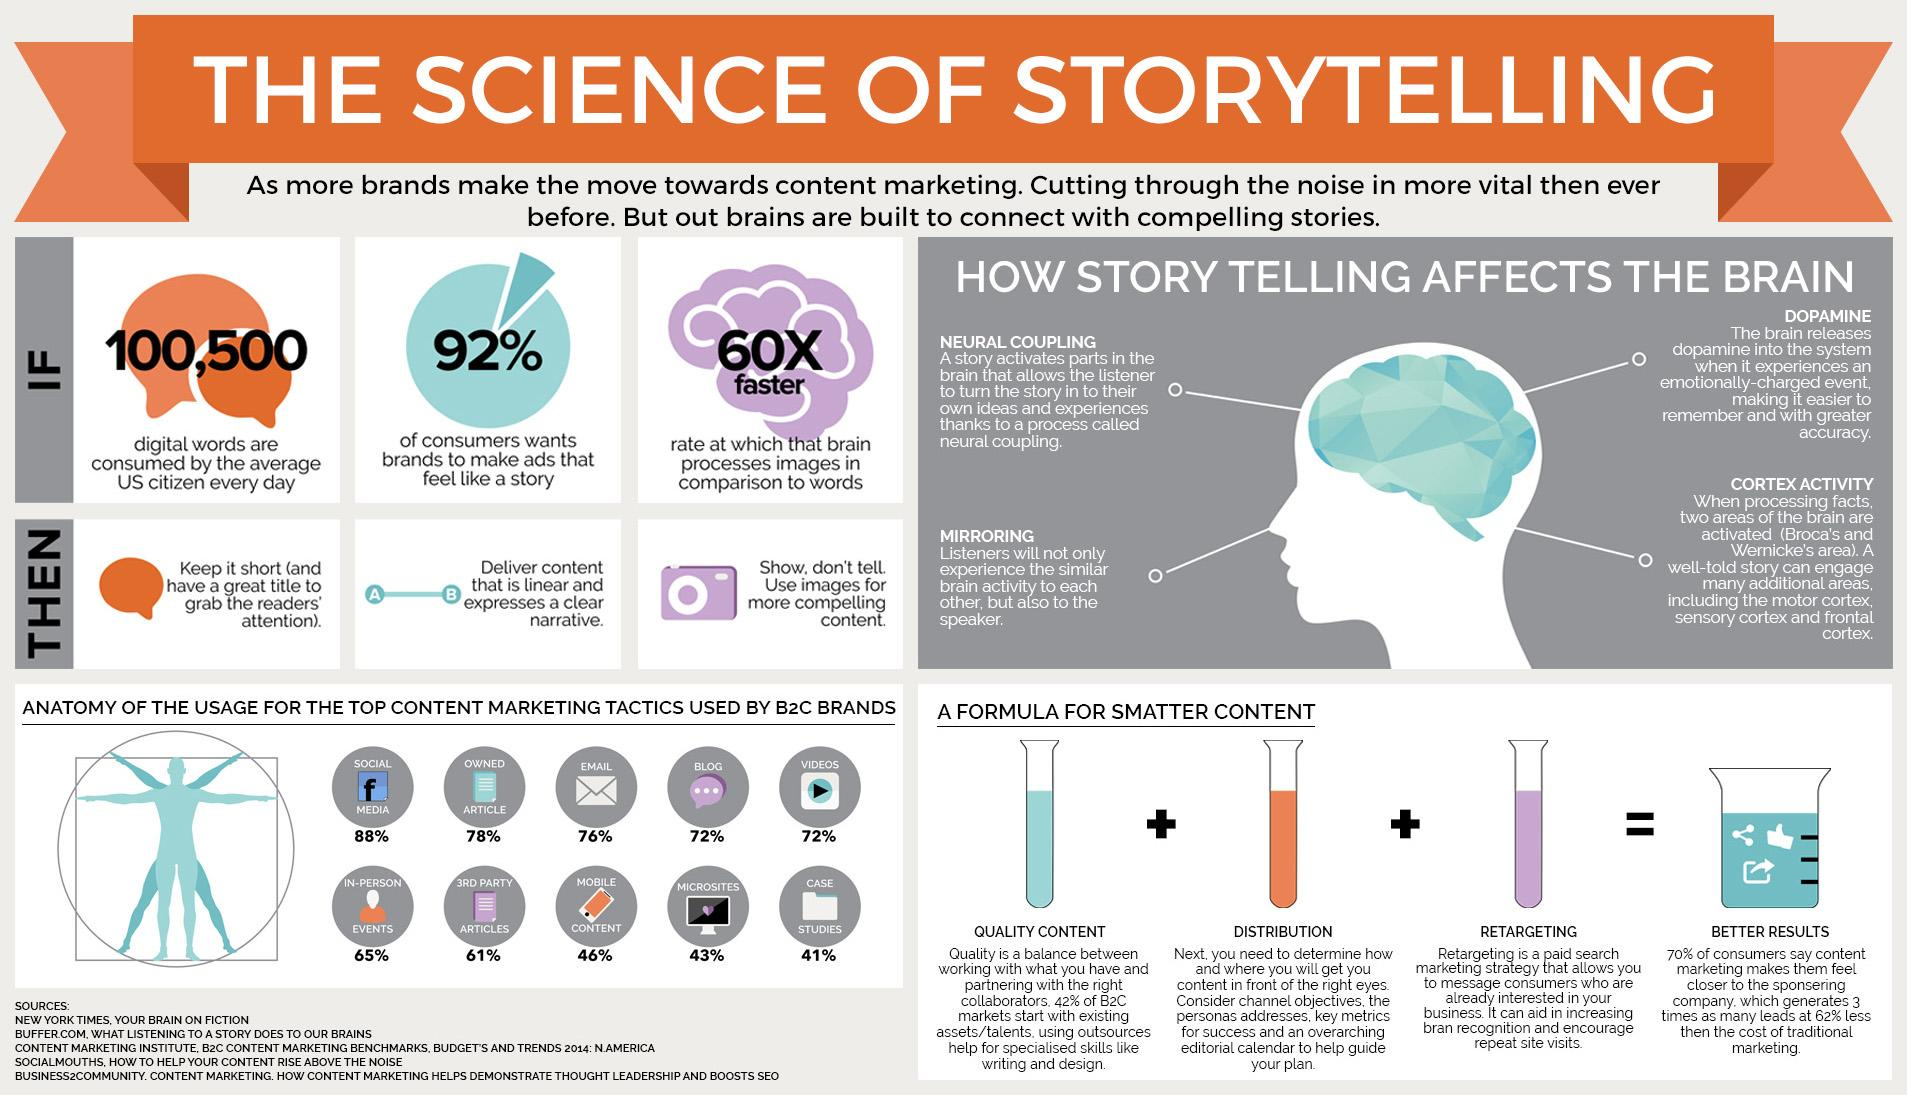Draw attention to some important aspects in this diagram. Approximately 72% of internet usage is dedicated to video content. According to a recent survey, 76% of people use email on a daily basis. The factors that contribute to high-quality content are superior content, effective distribution, and targeted retargeting. According to a recent study, 46% of all content consumed on the internet is accessed through mobile devices. Storytelling has been shown to have a significant impact on the brain, with various studies finding that it can alter brain activity in numerous ways. 